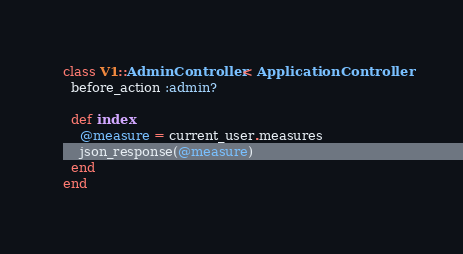Convert code to text. <code><loc_0><loc_0><loc_500><loc_500><_Ruby_>class V1::AdminController < ApplicationController
  before_action :admin?

  def index
    @measure = current_user.measures
    json_response(@measure)
  end
end
</code> 